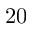Convert formula to latex. <formula><loc_0><loc_0><loc_500><loc_500>2 0</formula> 